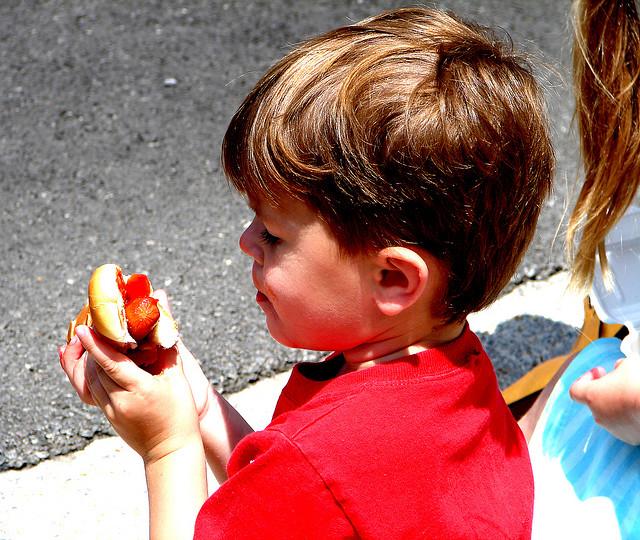Does the boy have shoulder length hair?
Write a very short answer. No. Did a president ever declare the condiment on the hot dog to be a vegetable?
Concise answer only. No. What is in his hands?
Keep it brief. Hot dog. 